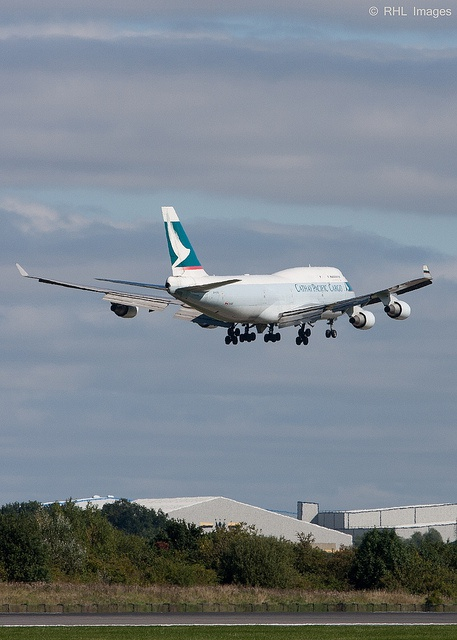Describe the objects in this image and their specific colors. I can see a airplane in darkgray, lightgray, black, and gray tones in this image. 